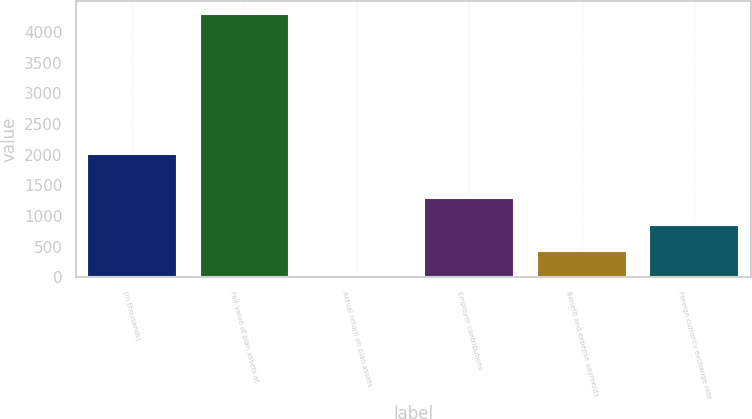Convert chart to OTSL. <chart><loc_0><loc_0><loc_500><loc_500><bar_chart><fcel>(in thousands)<fcel>Fair value of plan assets at<fcel>Actual return on plan assets<fcel>Employer contributions<fcel>Benefit and expense payments<fcel>Foreign currency exchange rate<nl><fcel>2005<fcel>4285<fcel>1<fcel>1286.2<fcel>429.4<fcel>857.8<nl></chart> 